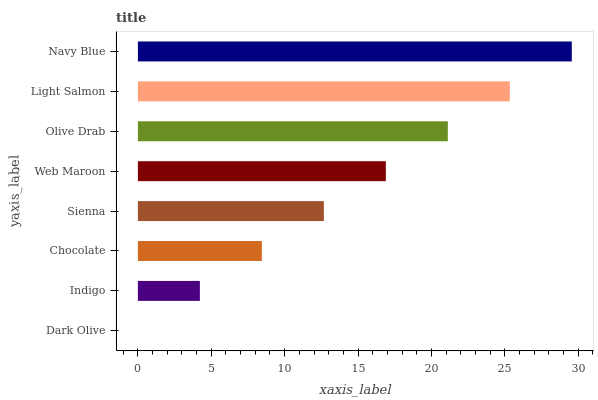Is Dark Olive the minimum?
Answer yes or no. Yes. Is Navy Blue the maximum?
Answer yes or no. Yes. Is Indigo the minimum?
Answer yes or no. No. Is Indigo the maximum?
Answer yes or no. No. Is Indigo greater than Dark Olive?
Answer yes or no. Yes. Is Dark Olive less than Indigo?
Answer yes or no. Yes. Is Dark Olive greater than Indigo?
Answer yes or no. No. Is Indigo less than Dark Olive?
Answer yes or no. No. Is Web Maroon the high median?
Answer yes or no. Yes. Is Sienna the low median?
Answer yes or no. Yes. Is Chocolate the high median?
Answer yes or no. No. Is Chocolate the low median?
Answer yes or no. No. 